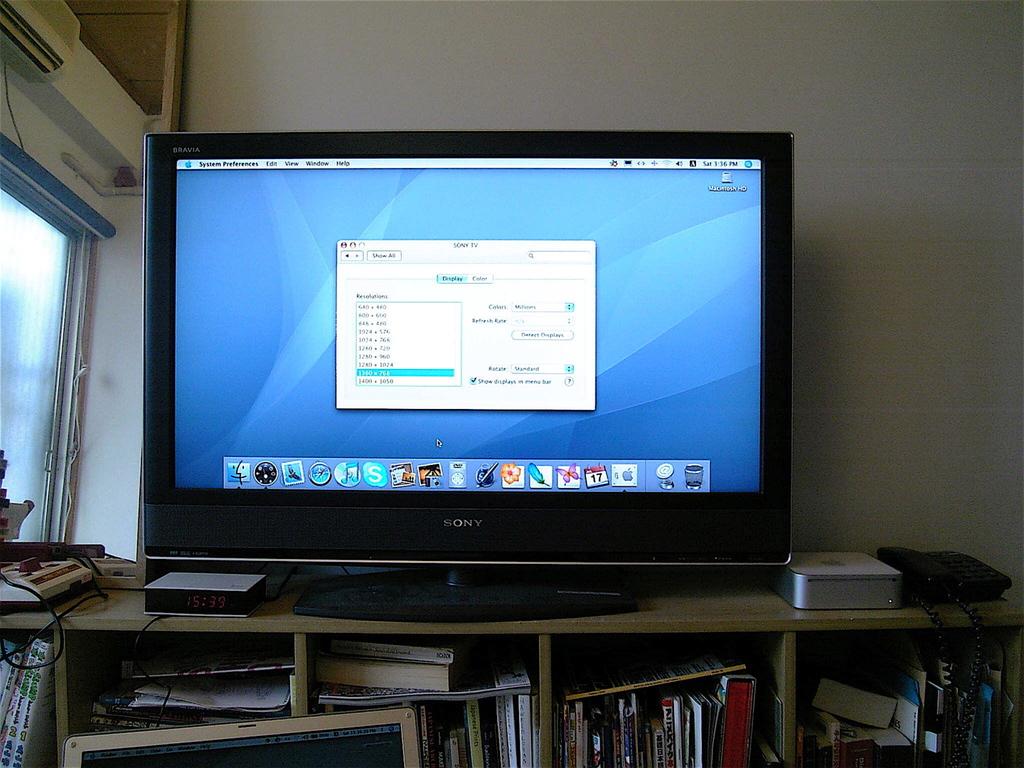Is this a mac?
Your response must be concise. Yes. 